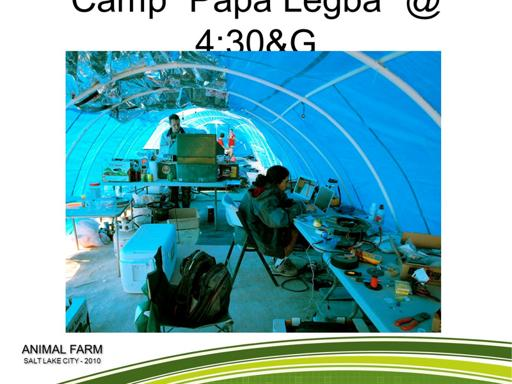What is the event mentioned in the image?
 The event mentioned in the image is Animal Farm in Salt Lake City, 2010. What time does the event start? The event starts at 4:30. 